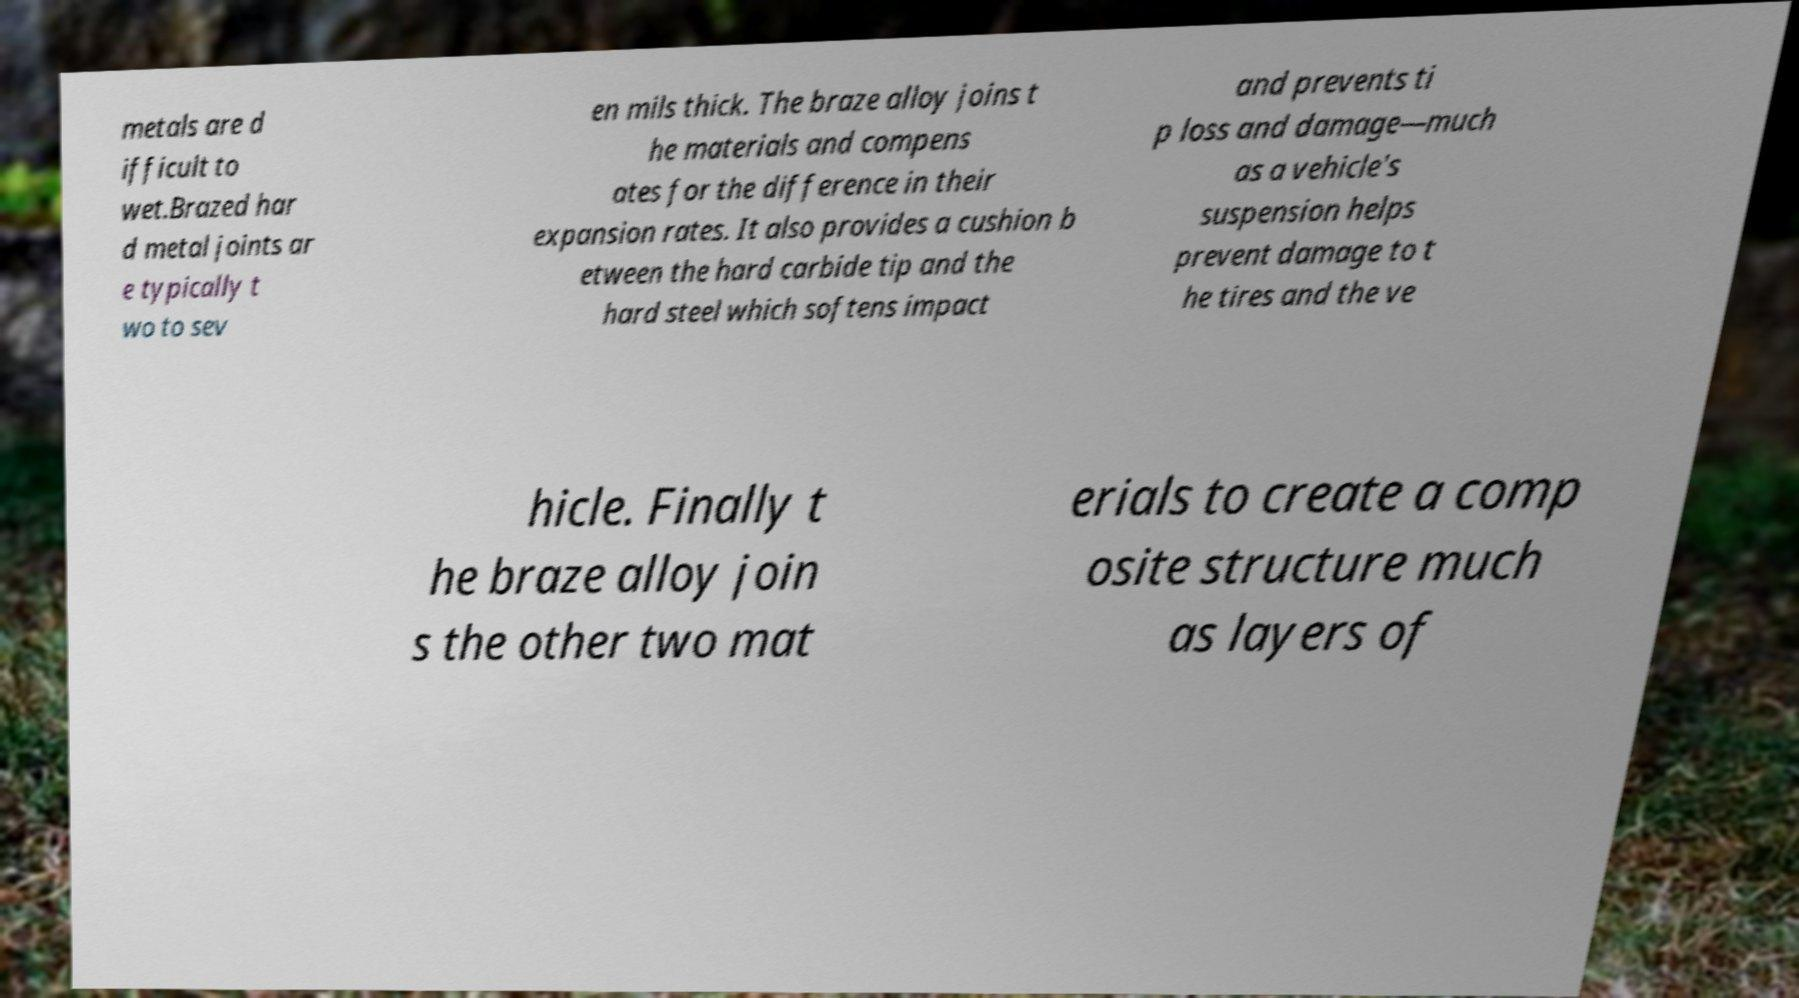Please read and relay the text visible in this image. What does it say? metals are d ifficult to wet.Brazed har d metal joints ar e typically t wo to sev en mils thick. The braze alloy joins t he materials and compens ates for the difference in their expansion rates. It also provides a cushion b etween the hard carbide tip and the hard steel which softens impact and prevents ti p loss and damage—much as a vehicle's suspension helps prevent damage to t he tires and the ve hicle. Finally t he braze alloy join s the other two mat erials to create a comp osite structure much as layers of 